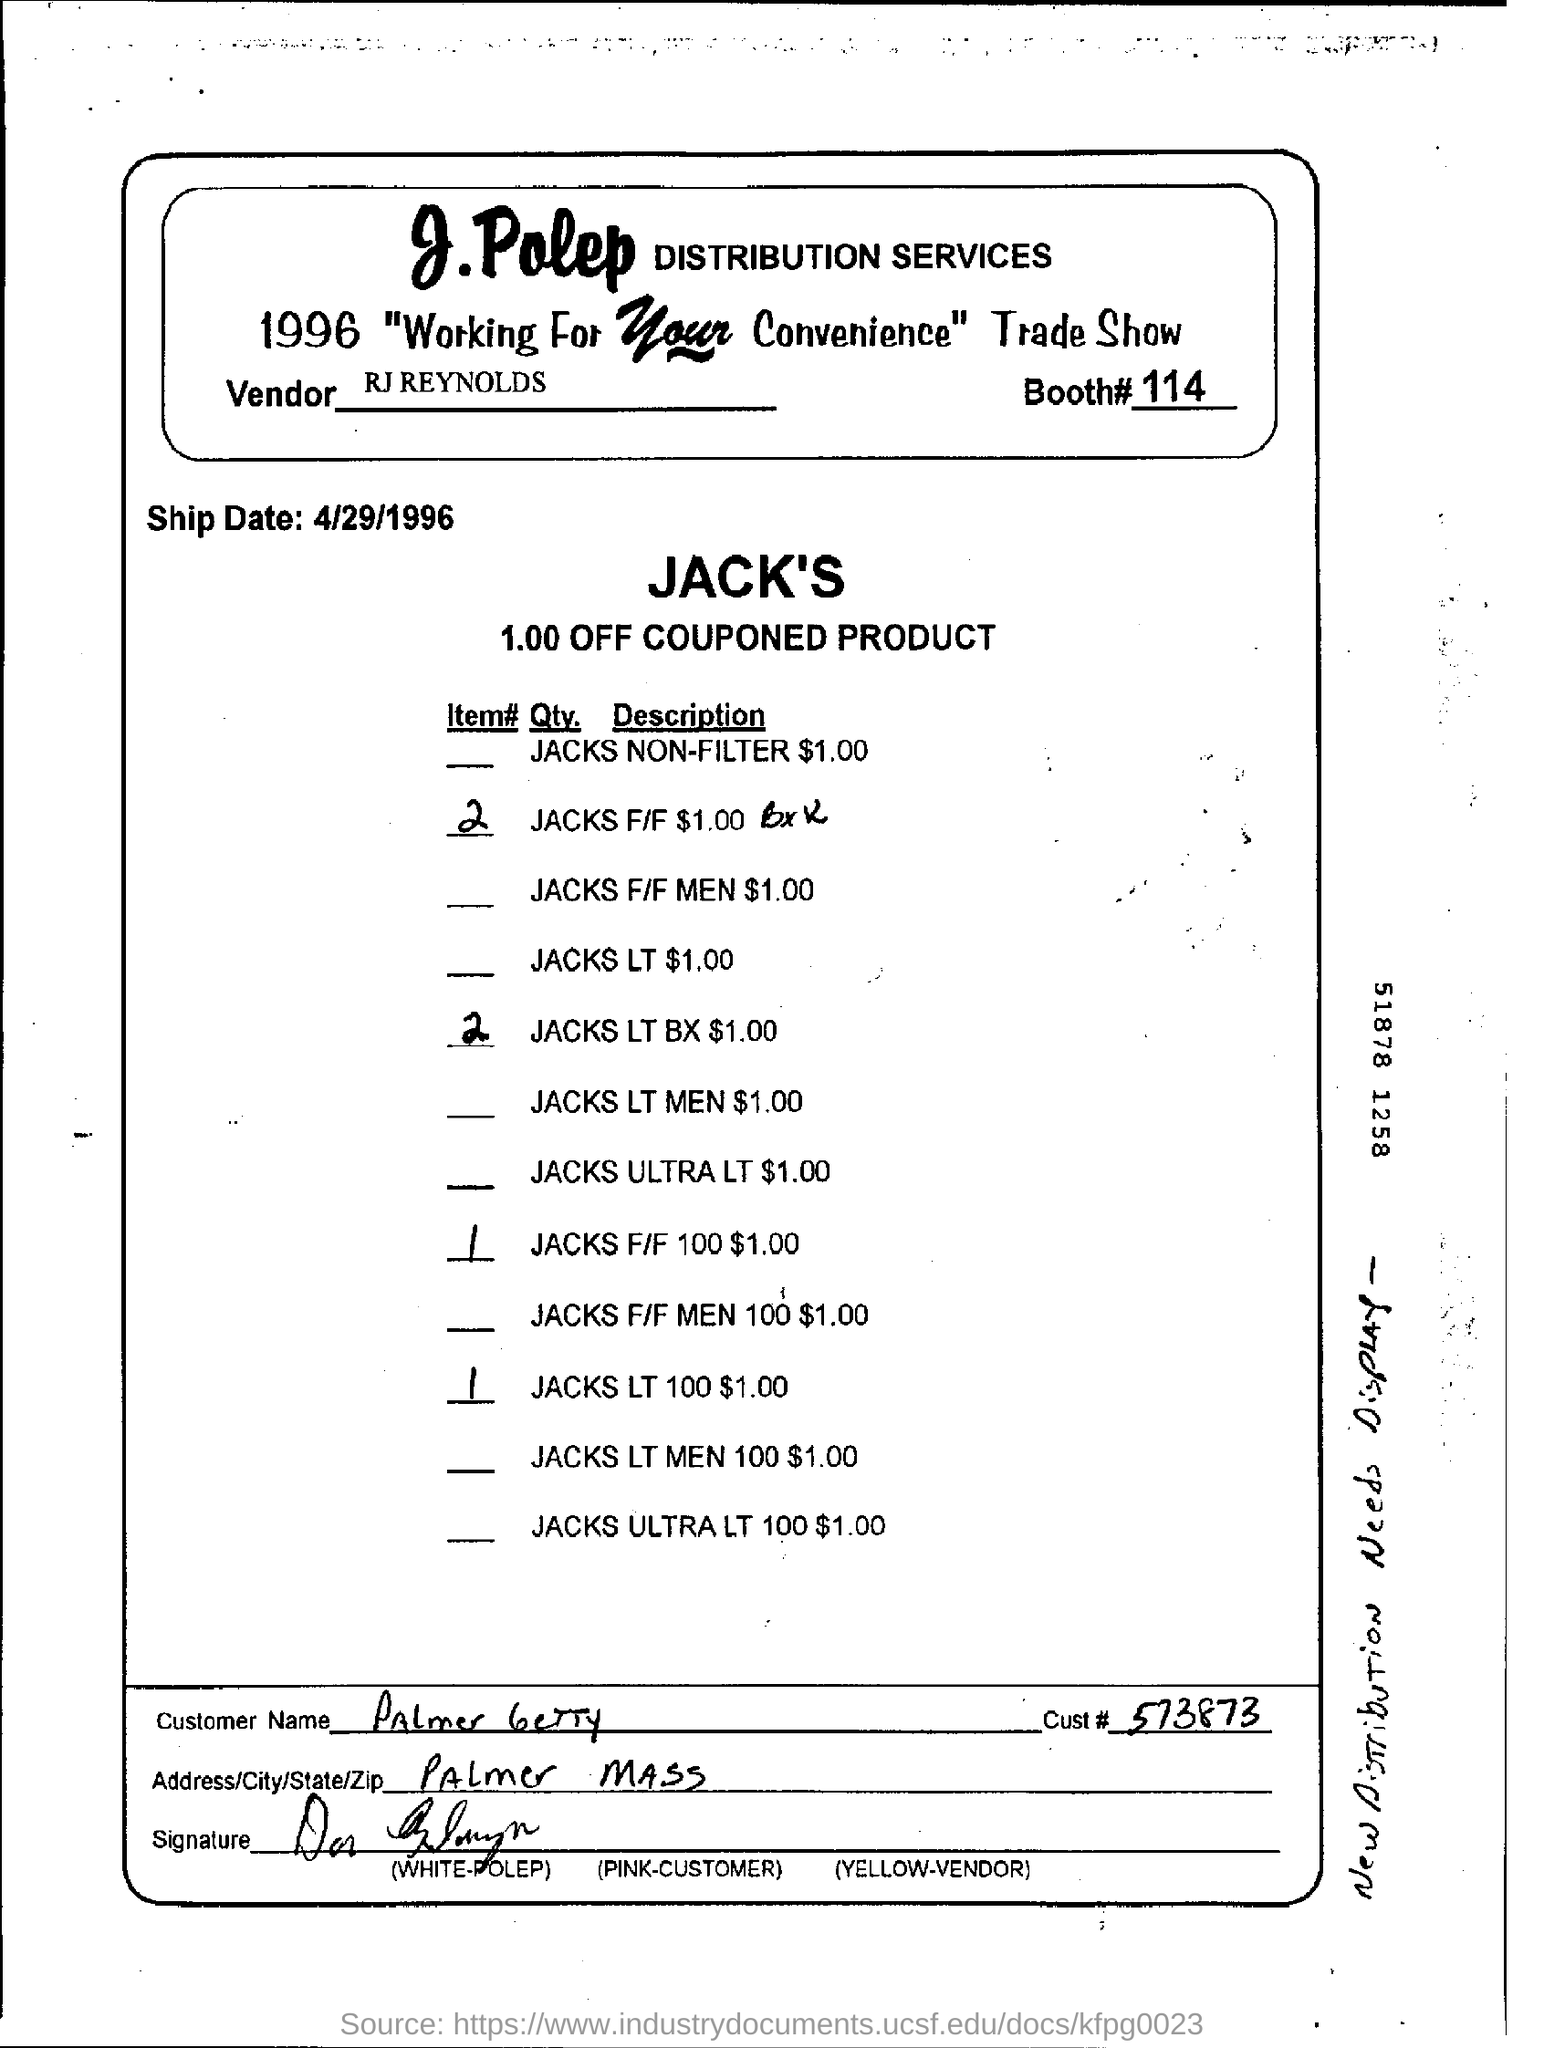Name the distribution services?
Give a very brief answer. J. Polep. What is ship date ?
Keep it short and to the point. 4/29/1996. 